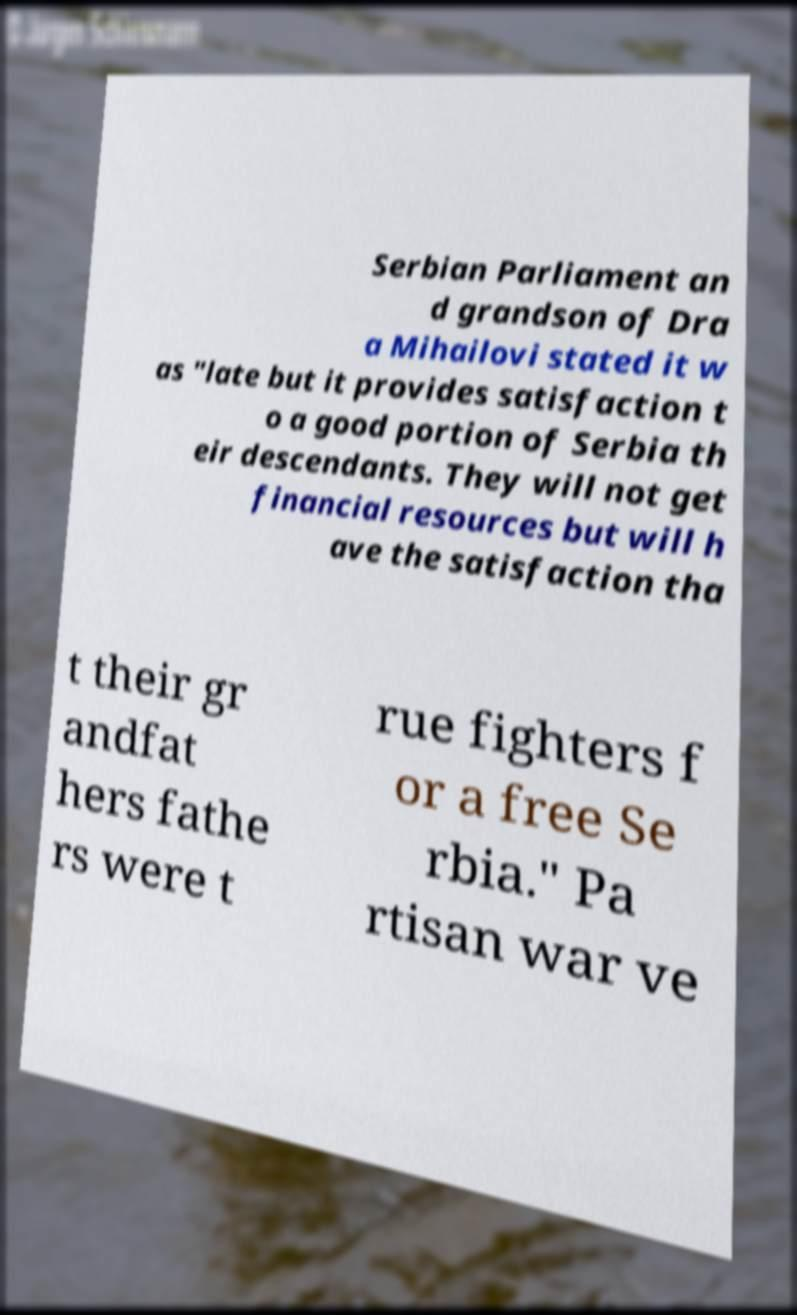Can you read and provide the text displayed in the image?This photo seems to have some interesting text. Can you extract and type it out for me? Serbian Parliament an d grandson of Dra a Mihailovi stated it w as "late but it provides satisfaction t o a good portion of Serbia th eir descendants. They will not get financial resources but will h ave the satisfaction tha t their gr andfat hers fathe rs were t rue fighters f or a free Se rbia." Pa rtisan war ve 